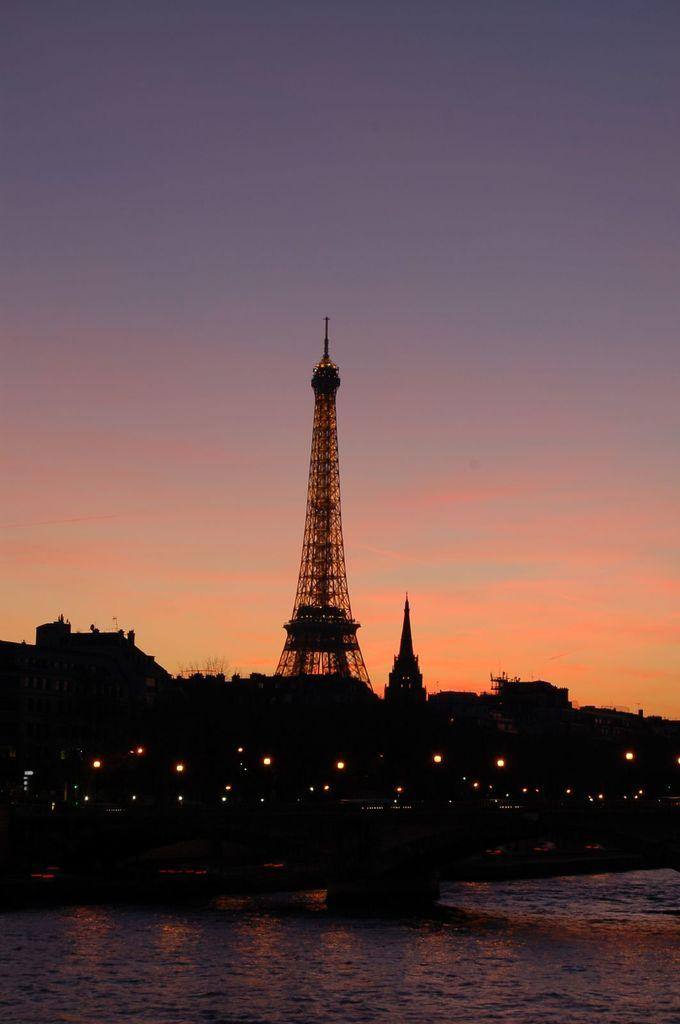What famous landmark is featured in the image? There is an Eiffel tower in the image. What is located in front of the Eiffel tower? There are lights in front of the Eiffel tower. What can be seen at the bottom of the image? There is water visible at the bottom of the image. What is visible in the background of the image? The sky is visible in the background of the image. How does the Eiffel tower act in the image? The Eiffel tower is an inanimate object and does not act in the image. 